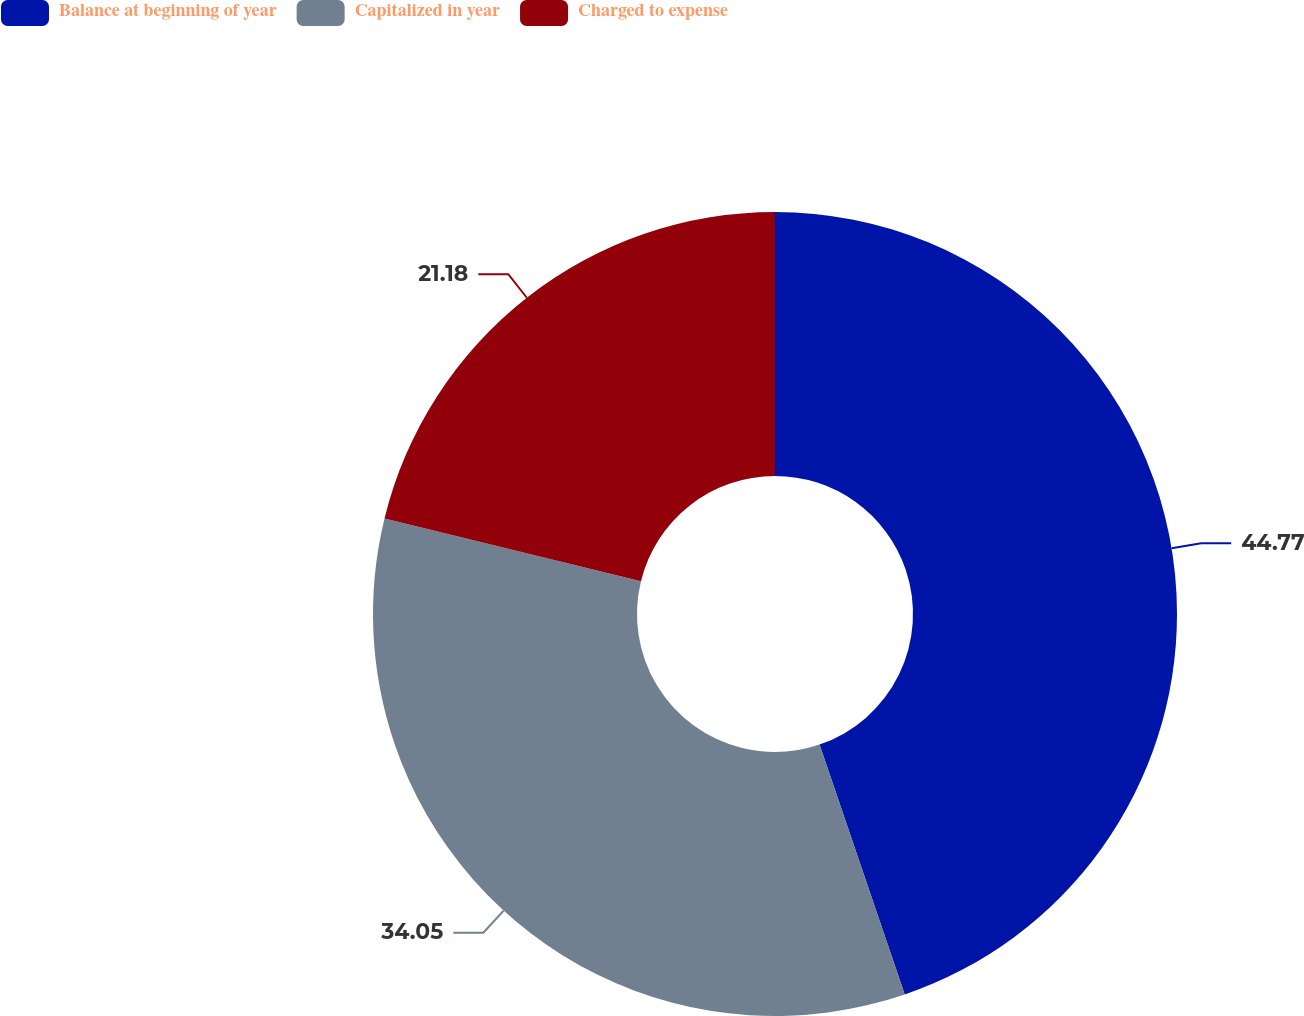Convert chart to OTSL. <chart><loc_0><loc_0><loc_500><loc_500><pie_chart><fcel>Balance at beginning of year<fcel>Capitalized in year<fcel>Charged to expense<nl><fcel>44.77%<fcel>34.05%<fcel>21.18%<nl></chart> 